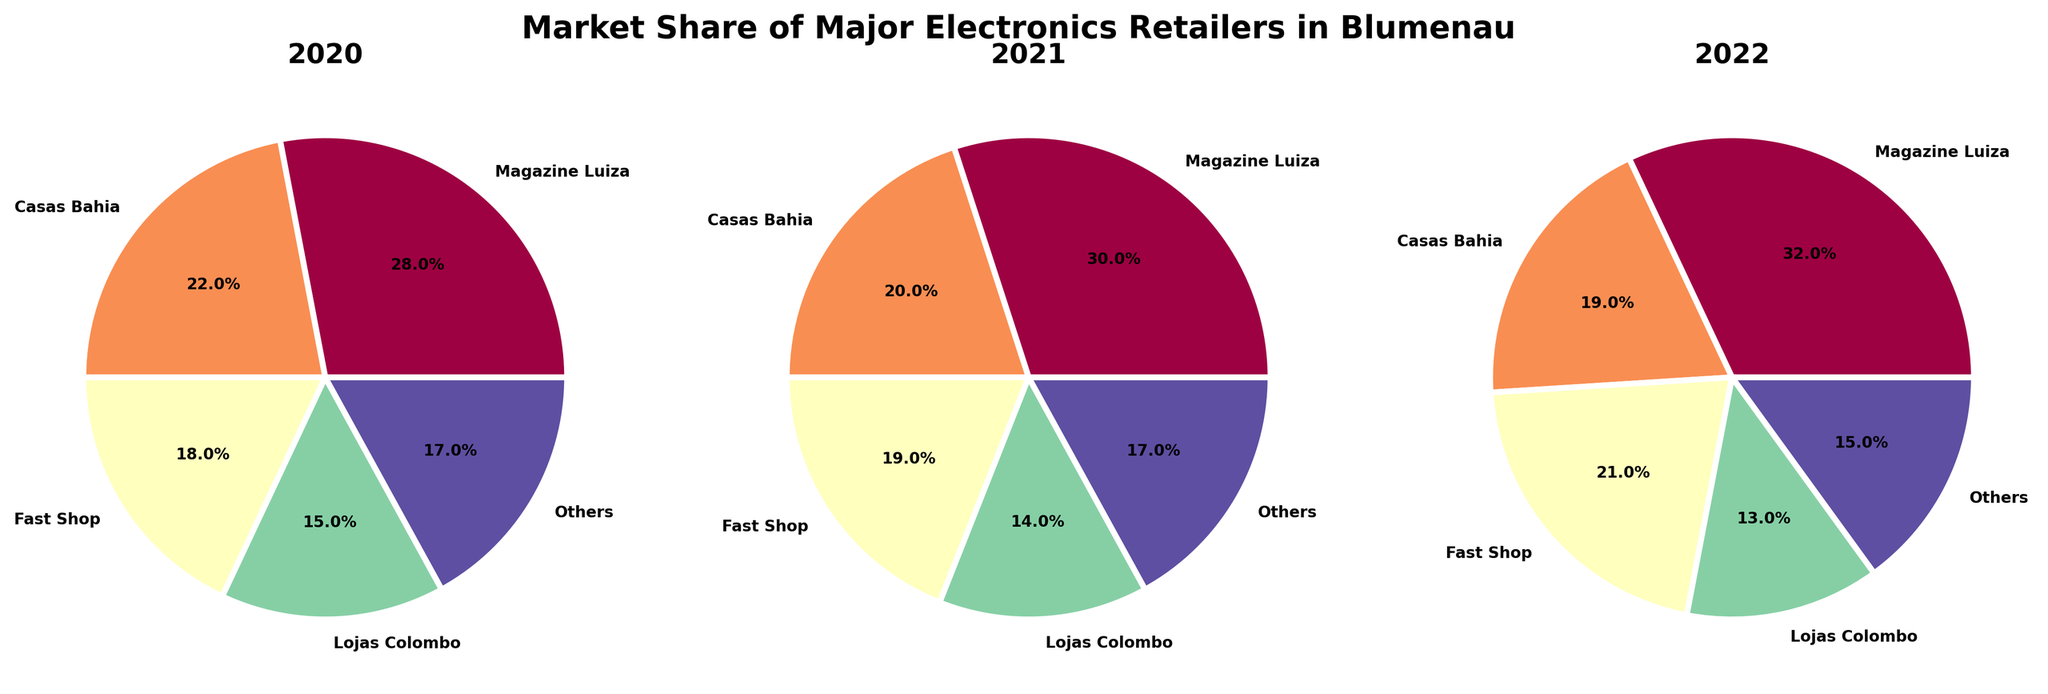What is the title of the figure? The title is displayed at the top of the figure, mentioning the market share of major electronics retailers in Blumenau.
Answer: Market Share of Major Electronics Retailers in Blumenau How many years are represented in the figure? The figure contains three separate pie charts, each labeled with a different year. Therefore, the number of years represented is three.
Answer: Three Which retailer had the highest market share in 2022? Looking at the 2022 pie chart, the segment labeled "Magazine Luiza" is the largest, indicating it had the highest market share in that year.
Answer: Magazine Luiza By how much did Fast Shop's market share increase from 2020 to 2022? Fast Shop had a market share of 18% in 2020 and 21% in 2022. The increase can be calculated as 21 - 18.
Answer: 3% What is the total market share percentage represented by "Others" across all three years? The pie charts show that "Others" had a market share of 17% in 2020, 17% in 2021, and 15% in 2022. Adding these percentages: 17 + 17 + 15.
Answer: 49% Which year saw the largest market share for Casas Bahia? By observing all three pie charts, the segment corresponding to Casas Bahia is largest in 2020 at 22%.
Answer: 2020 Compare the market share of Lojas Colombo between 2021 and 2022. Did it increase or decrease, and by how much? In 2021, Lojas Colombo had a market share of 14%. In 2022, it had 13%. To find the change, subtract 13 from 14.
Answer: Decrease, 1% Which retailer showed a consistent increase in market share over the three years? Observing the segments for each year, Magazine Luiza's share grew from 28% in 2020 to 30% in 2021, and then to 32% in 2022.
Answer: Magazine Luiza What was the combined market share of Magazine Luiza and Fast Shop in 2021? In 2021, Magazine Luiza had a market share of 30% and Fast Shop 19%. Adding these percentages: 30 + 19.
Answer: 49% Which retailer seems to have lost market share every year from 2020 to 2022? Comparing the pie charts, Lojas Colombo's segment shrinks each year from 15% in 2020 to 14% in 2021, and then to 13% in 2022.
Answer: Lojas Colombo 